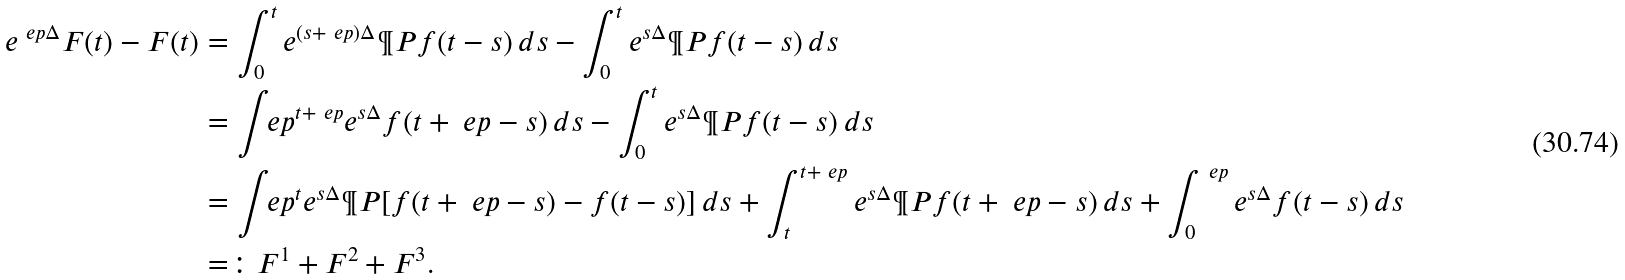<formula> <loc_0><loc_0><loc_500><loc_500>e ^ { \ e p \Delta } F ( t ) - F ( t ) & = \int _ { 0 } ^ { t } e ^ { ( s + \ e p ) \Delta } \P P f ( t - s ) \, d s - \int _ { 0 } ^ { t } e ^ { s \Delta } \P P f ( t - s ) \, d s \\ & = \int _ { \ } e p ^ { t + \ e p } e ^ { s \Delta } f ( t + \ e p - s ) \, d s - \int _ { 0 } ^ { t } e ^ { s \Delta } \P P f ( t - s ) \, d s \\ & = \int _ { \ } e p ^ { t } e ^ { s \Delta } \P P [ f ( t + \ e p - s ) - f ( t - s ) ] \, d s + \int _ { t } ^ { t + \ e p } e ^ { s \Delta } \P P f ( t + \ e p - s ) \, d s + \int _ { 0 } ^ { \ e p } e ^ { s \Delta } f ( t - s ) \, d s \\ & = \colon F ^ { 1 } + F ^ { 2 } + F ^ { 3 } .</formula> 